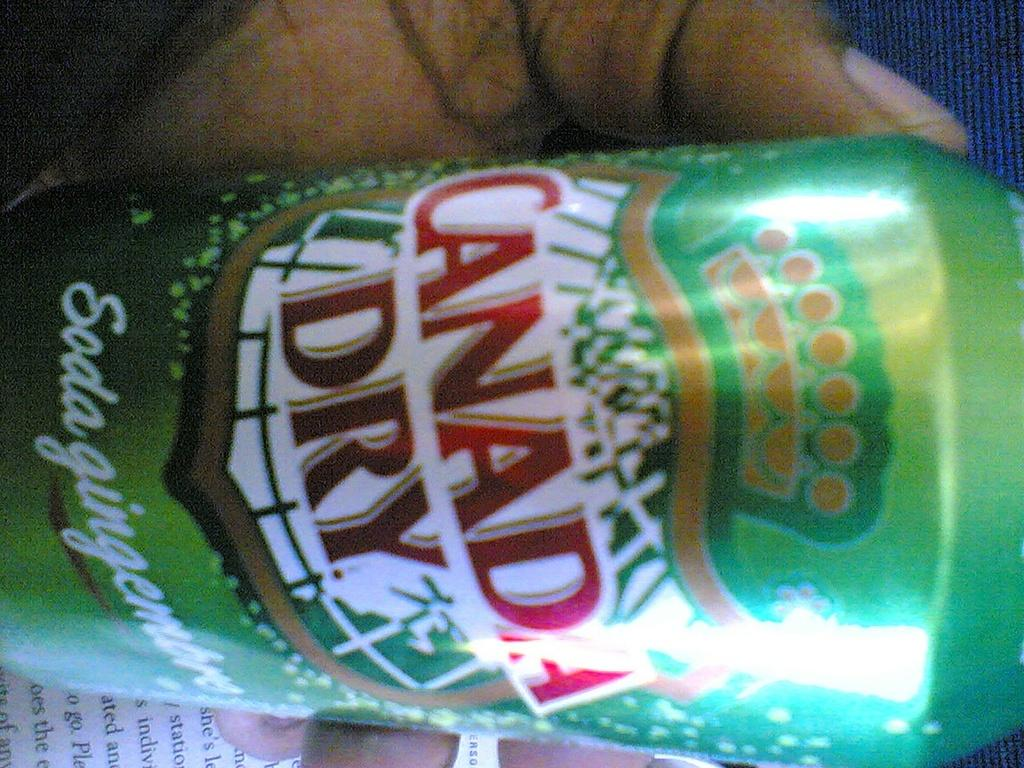<image>
Describe the image concisely. A person holds a can of Canada Dry at an angle. 